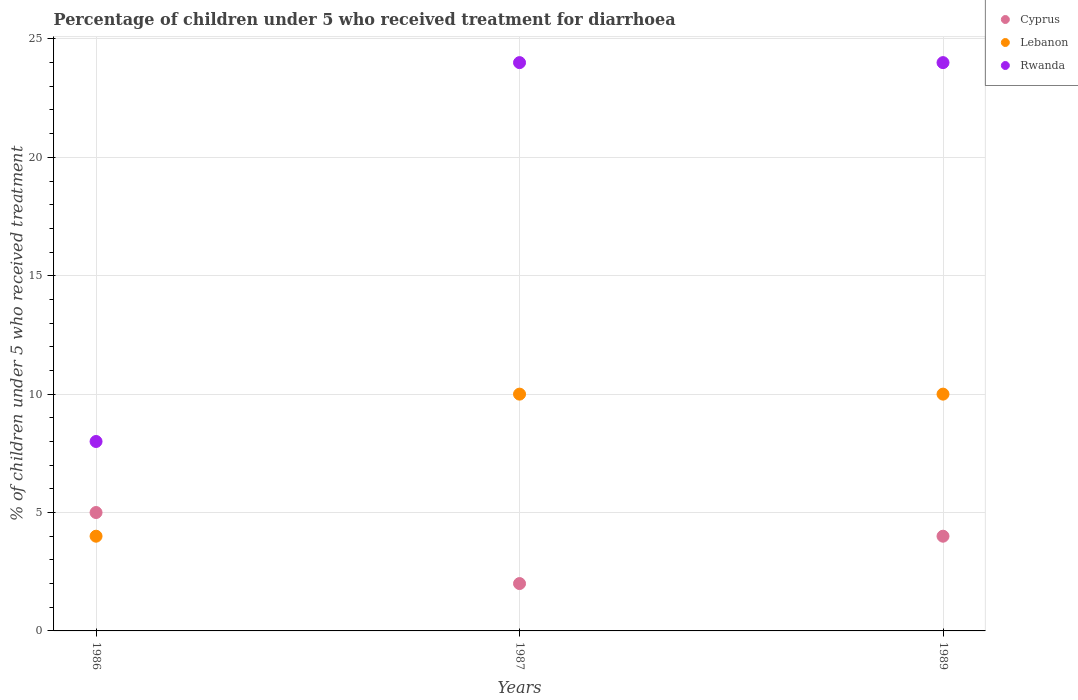How many different coloured dotlines are there?
Your response must be concise. 3. Is the number of dotlines equal to the number of legend labels?
Your response must be concise. Yes. What is the percentage of children who received treatment for diarrhoea  in Lebanon in 1989?
Make the answer very short. 10. Across all years, what is the maximum percentage of children who received treatment for diarrhoea  in Lebanon?
Your answer should be very brief. 10. Across all years, what is the minimum percentage of children who received treatment for diarrhoea  in Cyprus?
Offer a terse response. 2. In which year was the percentage of children who received treatment for diarrhoea  in Rwanda maximum?
Your answer should be compact. 1987. What is the difference between the percentage of children who received treatment for diarrhoea  in Rwanda in 1987 and that in 1989?
Provide a succinct answer. 0. What is the difference between the percentage of children who received treatment for diarrhoea  in Lebanon in 1989 and the percentage of children who received treatment for diarrhoea  in Cyprus in 1987?
Your response must be concise. 8. What is the average percentage of children who received treatment for diarrhoea  in Rwanda per year?
Give a very brief answer. 18.67. Is the percentage of children who received treatment for diarrhoea  in Cyprus in 1986 less than that in 1989?
Offer a terse response. No. In how many years, is the percentage of children who received treatment for diarrhoea  in Cyprus greater than the average percentage of children who received treatment for diarrhoea  in Cyprus taken over all years?
Make the answer very short. 2. Is the sum of the percentage of children who received treatment for diarrhoea  in Lebanon in 1986 and 1989 greater than the maximum percentage of children who received treatment for diarrhoea  in Rwanda across all years?
Your answer should be very brief. No. Does the percentage of children who received treatment for diarrhoea  in Rwanda monotonically increase over the years?
Your answer should be compact. No. Is the percentage of children who received treatment for diarrhoea  in Lebanon strictly greater than the percentage of children who received treatment for diarrhoea  in Cyprus over the years?
Keep it short and to the point. No. Is the percentage of children who received treatment for diarrhoea  in Cyprus strictly less than the percentage of children who received treatment for diarrhoea  in Rwanda over the years?
Give a very brief answer. Yes. How many dotlines are there?
Give a very brief answer. 3. Are the values on the major ticks of Y-axis written in scientific E-notation?
Provide a short and direct response. No. Where does the legend appear in the graph?
Your response must be concise. Top right. How are the legend labels stacked?
Provide a short and direct response. Vertical. What is the title of the graph?
Provide a short and direct response. Percentage of children under 5 who received treatment for diarrhoea. What is the label or title of the X-axis?
Offer a terse response. Years. What is the label or title of the Y-axis?
Your answer should be very brief. % of children under 5 who received treatment. What is the % of children under 5 who received treatment of Cyprus in 1987?
Provide a succinct answer. 2. What is the % of children under 5 who received treatment of Lebanon in 1989?
Offer a terse response. 10. Across all years, what is the maximum % of children under 5 who received treatment of Cyprus?
Keep it short and to the point. 5. Across all years, what is the maximum % of children under 5 who received treatment of Lebanon?
Your answer should be compact. 10. Across all years, what is the maximum % of children under 5 who received treatment of Rwanda?
Provide a short and direct response. 24. Across all years, what is the minimum % of children under 5 who received treatment of Cyprus?
Provide a succinct answer. 2. Across all years, what is the minimum % of children under 5 who received treatment of Rwanda?
Offer a terse response. 8. What is the total % of children under 5 who received treatment of Cyprus in the graph?
Ensure brevity in your answer.  11. What is the total % of children under 5 who received treatment in Lebanon in the graph?
Give a very brief answer. 24. What is the difference between the % of children under 5 who received treatment of Cyprus in 1986 and that in 1987?
Provide a succinct answer. 3. What is the difference between the % of children under 5 who received treatment in Cyprus in 1986 and that in 1989?
Ensure brevity in your answer.  1. What is the difference between the % of children under 5 who received treatment of Cyprus in 1987 and that in 1989?
Ensure brevity in your answer.  -2. What is the difference between the % of children under 5 who received treatment in Rwanda in 1987 and that in 1989?
Keep it short and to the point. 0. What is the difference between the % of children under 5 who received treatment in Lebanon in 1986 and the % of children under 5 who received treatment in Rwanda in 1987?
Give a very brief answer. -20. What is the average % of children under 5 who received treatment of Cyprus per year?
Ensure brevity in your answer.  3.67. What is the average % of children under 5 who received treatment in Lebanon per year?
Provide a short and direct response. 8. What is the average % of children under 5 who received treatment of Rwanda per year?
Your answer should be very brief. 18.67. In the year 1986, what is the difference between the % of children under 5 who received treatment of Cyprus and % of children under 5 who received treatment of Rwanda?
Your answer should be compact. -3. In the year 1986, what is the difference between the % of children under 5 who received treatment of Lebanon and % of children under 5 who received treatment of Rwanda?
Provide a short and direct response. -4. What is the ratio of the % of children under 5 who received treatment in Lebanon in 1986 to that in 1987?
Make the answer very short. 0.4. What is the ratio of the % of children under 5 who received treatment of Cyprus in 1986 to that in 1989?
Your response must be concise. 1.25. What is the ratio of the % of children under 5 who received treatment of Rwanda in 1986 to that in 1989?
Make the answer very short. 0.33. What is the ratio of the % of children under 5 who received treatment of Cyprus in 1987 to that in 1989?
Your answer should be very brief. 0.5. What is the ratio of the % of children under 5 who received treatment of Lebanon in 1987 to that in 1989?
Your answer should be very brief. 1. What is the ratio of the % of children under 5 who received treatment of Rwanda in 1987 to that in 1989?
Provide a succinct answer. 1. What is the difference between the highest and the second highest % of children under 5 who received treatment of Cyprus?
Your response must be concise. 1. What is the difference between the highest and the second highest % of children under 5 who received treatment of Lebanon?
Offer a very short reply. 0. 